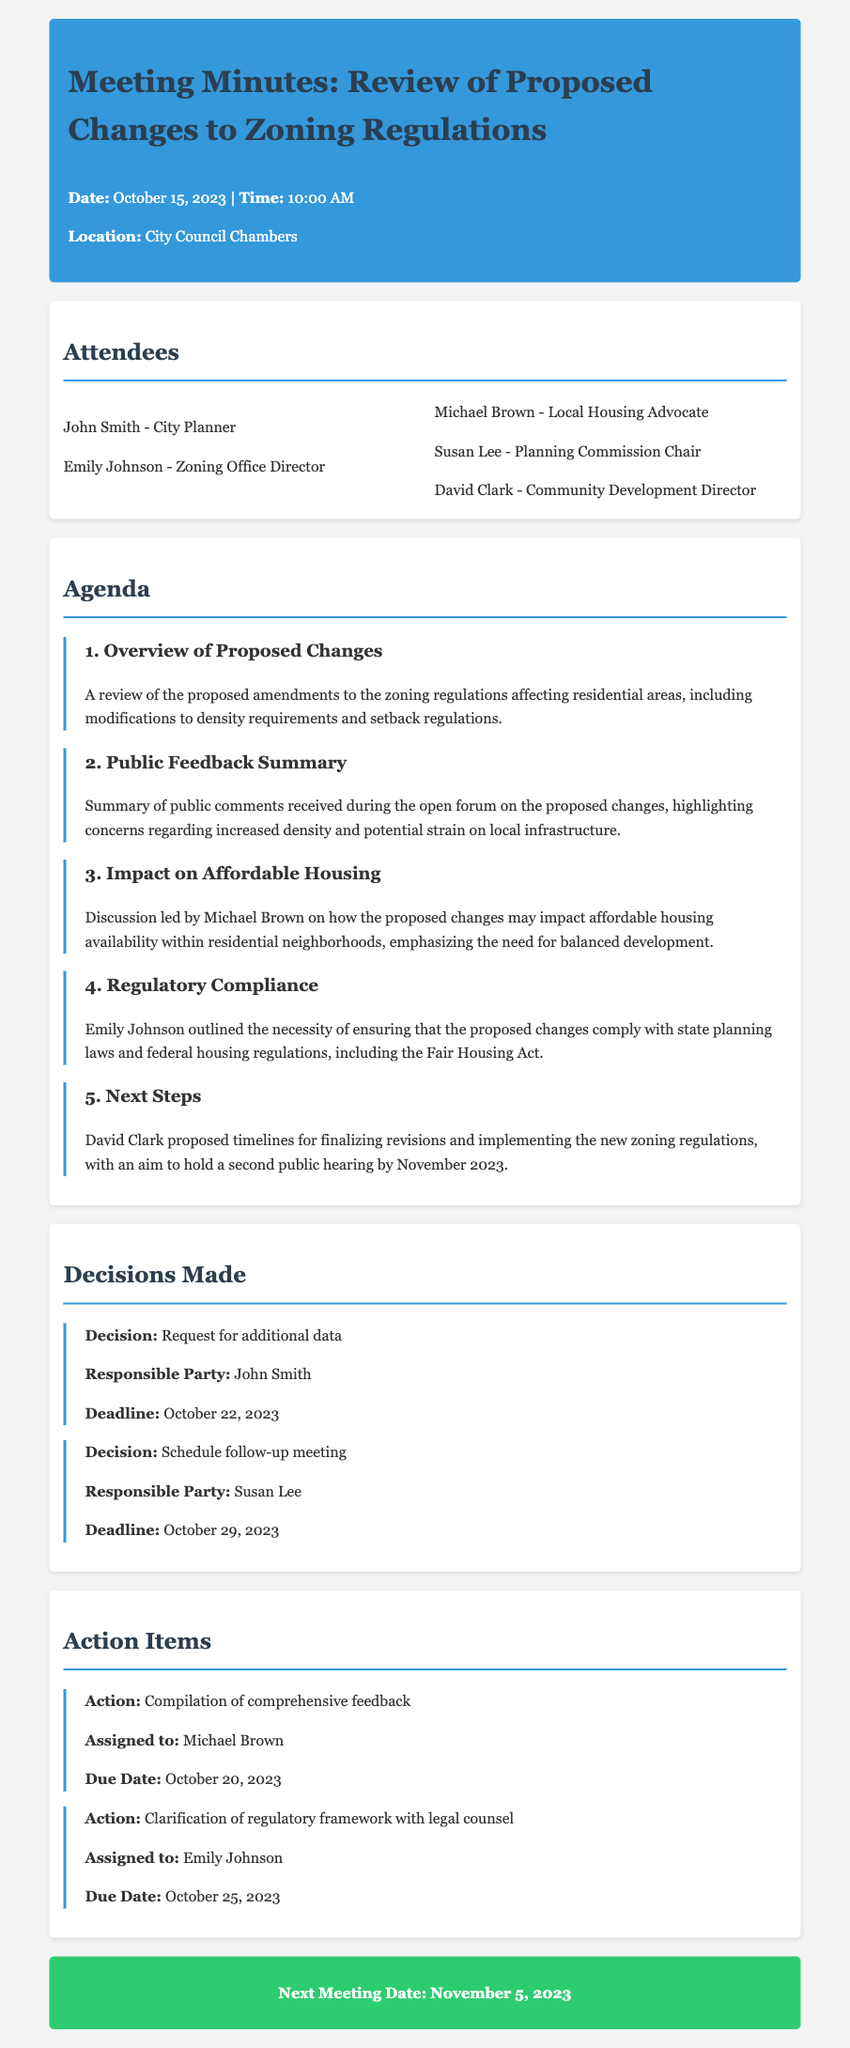What is the date of the meeting? The date of the meeting is listed at the top of the document.
Answer: October 15, 2023 Who is the Planning Commission Chair? The name of the Planning Commission Chair can be found in the list of attendees.
Answer: Susan Lee What is the proposed timeline for the next public hearing? The timeline for the next public hearing is mentioned in the "Next Steps" section of the document.
Answer: November 2023 What decision was made regarding additional data? The decision about additional data is highlighted in the "Decisions Made" section.
Answer: Request for additional data Who is responsible for compiling comprehensive feedback? This responsibility is assigned in the "Action Items" section.
Answer: Michael Brown Which regulatory act must the proposed changes comply with? The regulatory act is mentioned during the discussion on regulatory compliance.
Answer: Fair Housing Act What is the deadline for clarifying the regulatory framework with legal counsel? This deadline can be found in the "Action Items" section.
Answer: October 25, 2023 What is the primary concern raised in the public feedback summary? The primary concern is highlighted in the summary of public comments.
Answer: Increased density 